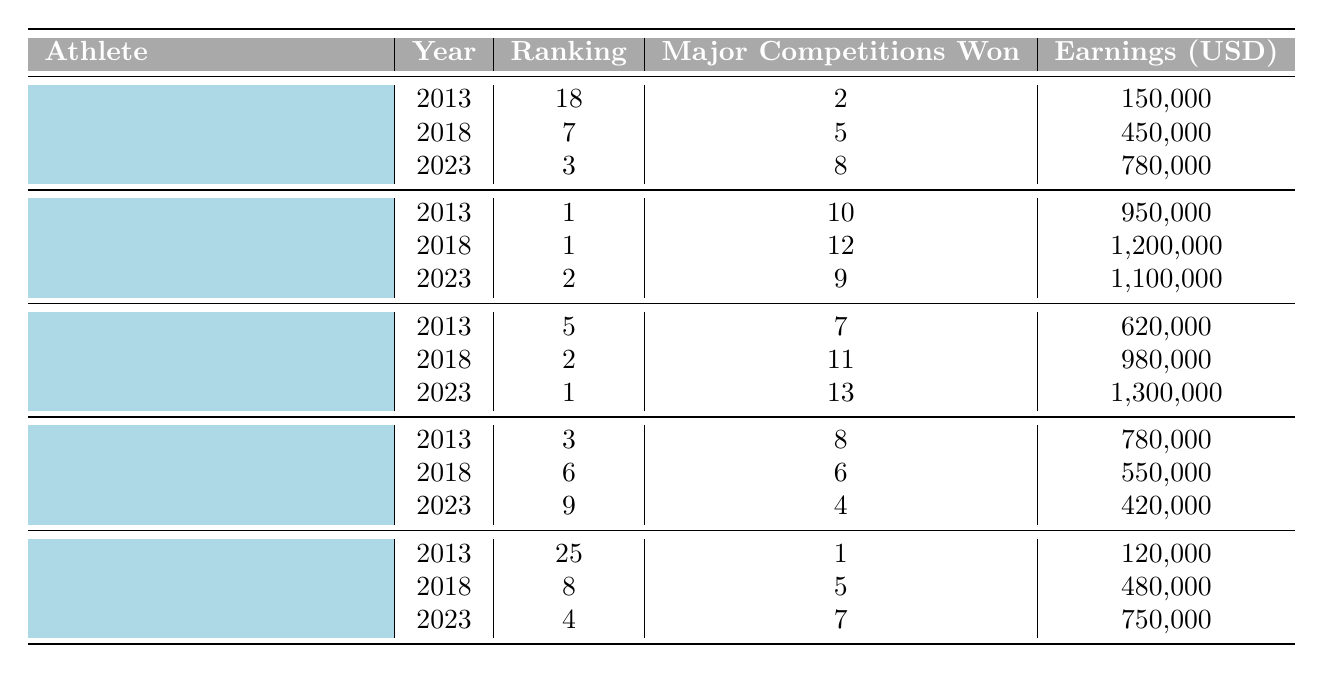What was Huang Zhuoqin's ranking in 2018? Huang Zhuoqin's data for 2018 shows a ranking of 7.
Answer: 7 How many major competitions did Mclain Ward win in 2023? In 2023, Mclain Ward's data indicates he won 13 major competitions.
Answer: 13 Who had the highest earnings in 2013? The table shows that Steve Guerdat had the highest earnings in 2013 at 950,000 USD.
Answer: 950,000 What is the difference in major competitions won by Edwina Tops-Alexander from 2013 to 2023? In 2013, Edwina won 8 competitions, and in 2023, she won 4. The difference is 8 - 4 = 4.
Answer: 4 Did Martin Fuchs earn more in 2018 than in 2023? In 2018, Martin Fuchs earned 480,000 USD, while in 2023 he earned 750,000 USD, indicating he earned more in 2023.
Answer: Yes What is the average ranking for Huang Zhuoqin over the years presented? Huang Zhuoqin's rankings are 18 in 2013, 7 in 2018, and 3 in 2023. The average is (18 + 7 + 3)/3 = 9.33.
Answer: 9.33 How many major competitions in total did Steve Guerdat win from 2013 to 2023? Steve Guerdat won 10 competitions in 2013, 12 in 2018, and 9 in 2023. The total is 10 + 12 + 9 = 31.
Answer: 31 Which athlete showed the most improvement in ranking from 2013 to 2023? Comparing rankings, Huang Zhuoqin improved from 18 to 3 (15 places), while Mclain Ward improved from 5 to 1 (4 places). Thus, Huang Zhuoqin showed the most improvement.
Answer: Huang Zhuoqin What was the highest ranking for Mclain Ward in the years presented? Mclain Ward's rankings were 5 in 2013, 2 in 2018, and 1 in 2023. Therefore, the highest ranking was 1 in 2023.
Answer: 1 What is the total earnings of Edwina Tops-Alexander over the given years? Edwina earned 780,000 in 2013, 550,000 in 2018, and 420,000 in 2023. The total earnings are 780,000 + 550,000 + 420,000 = 1,750,000.
Answer: 1,750,000 